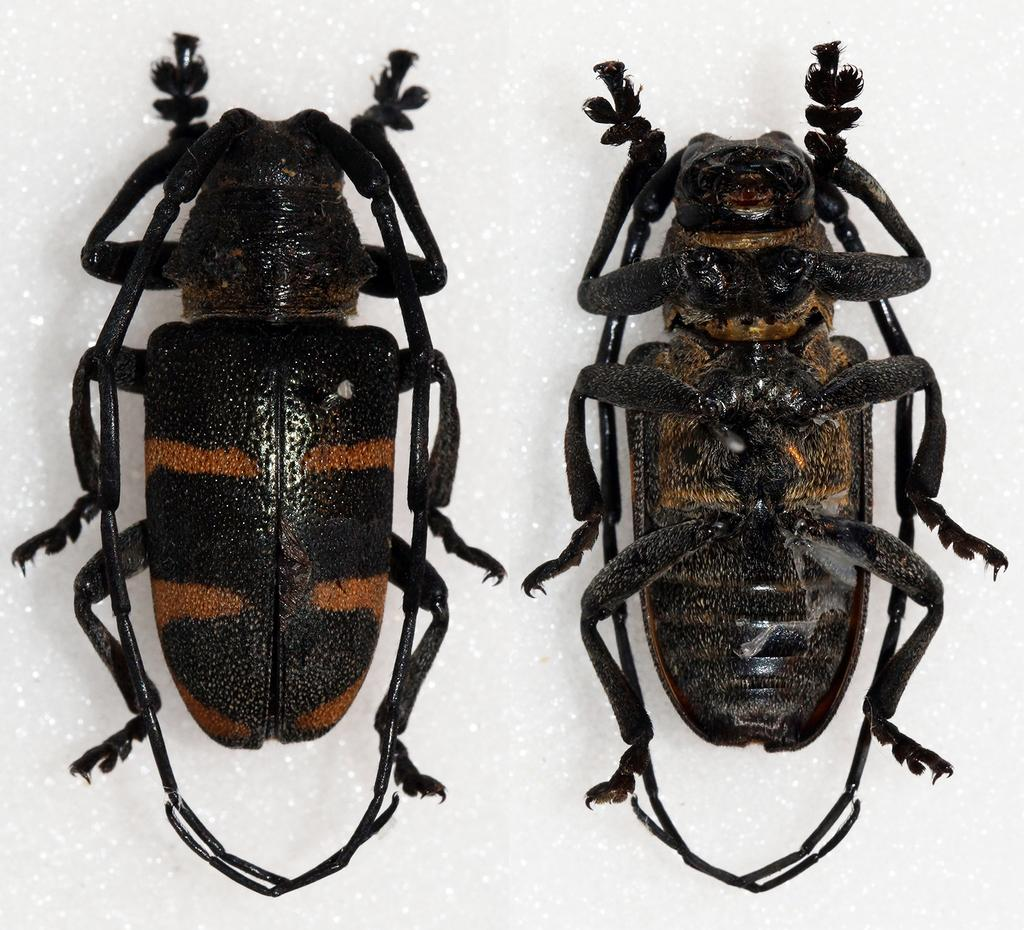What type of insects are present in the image? There are two longhorn beetles in the image. What color is the background of the image? The background of the image is white in color. What type of liquid can be seen dripping from the kitty in the image? There is no kitty or liquid present in the image; it features two longhorn beetles against a white background. 